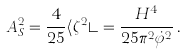Convert formula to latex. <formula><loc_0><loc_0><loc_500><loc_500>A _ { S } ^ { 2 } = \frac { 4 } { 2 5 } \langle \zeta ^ { 2 } \rangle = \frac { H ^ { 4 } } { 2 5 \pi ^ { 2 } \dot { \varphi } ^ { 2 } } \, .</formula> 